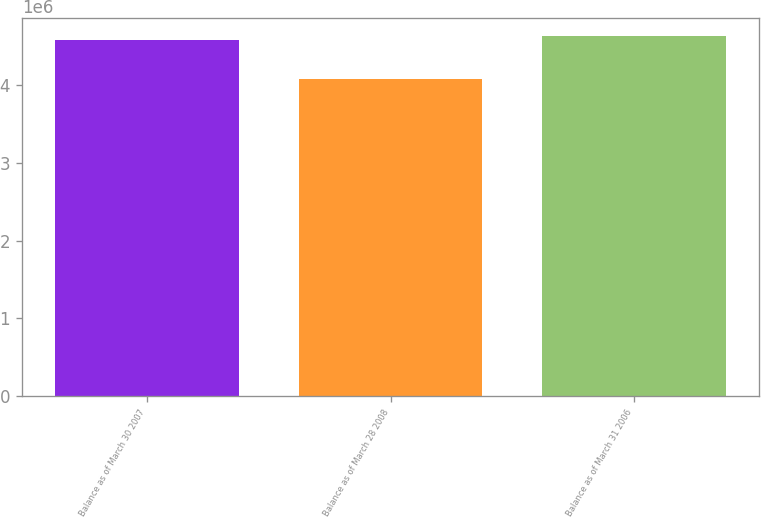Convert chart to OTSL. <chart><loc_0><loc_0><loc_500><loc_500><bar_chart><fcel>Balance as of March 30 2007<fcel>Balance as of March 28 2008<fcel>Balance as of March 31 2006<nl><fcel>4.58207e+06<fcel>4.08072e+06<fcel>4.63379e+06<nl></chart> 